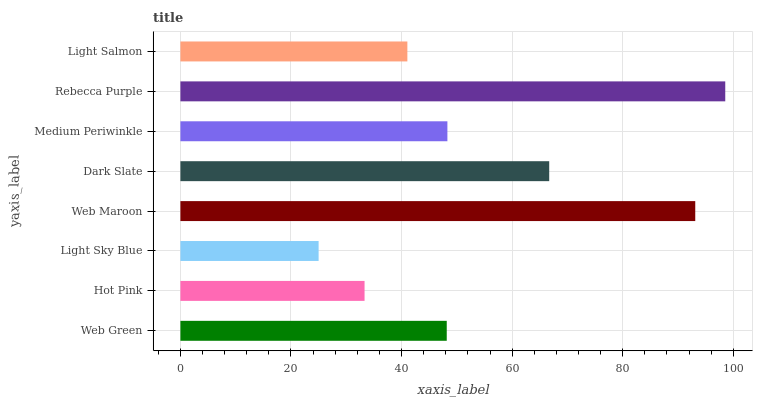Is Light Sky Blue the minimum?
Answer yes or no. Yes. Is Rebecca Purple the maximum?
Answer yes or no. Yes. Is Hot Pink the minimum?
Answer yes or no. No. Is Hot Pink the maximum?
Answer yes or no. No. Is Web Green greater than Hot Pink?
Answer yes or no. Yes. Is Hot Pink less than Web Green?
Answer yes or no. Yes. Is Hot Pink greater than Web Green?
Answer yes or no. No. Is Web Green less than Hot Pink?
Answer yes or no. No. Is Medium Periwinkle the high median?
Answer yes or no. Yes. Is Web Green the low median?
Answer yes or no. Yes. Is Dark Slate the high median?
Answer yes or no. No. Is Light Sky Blue the low median?
Answer yes or no. No. 